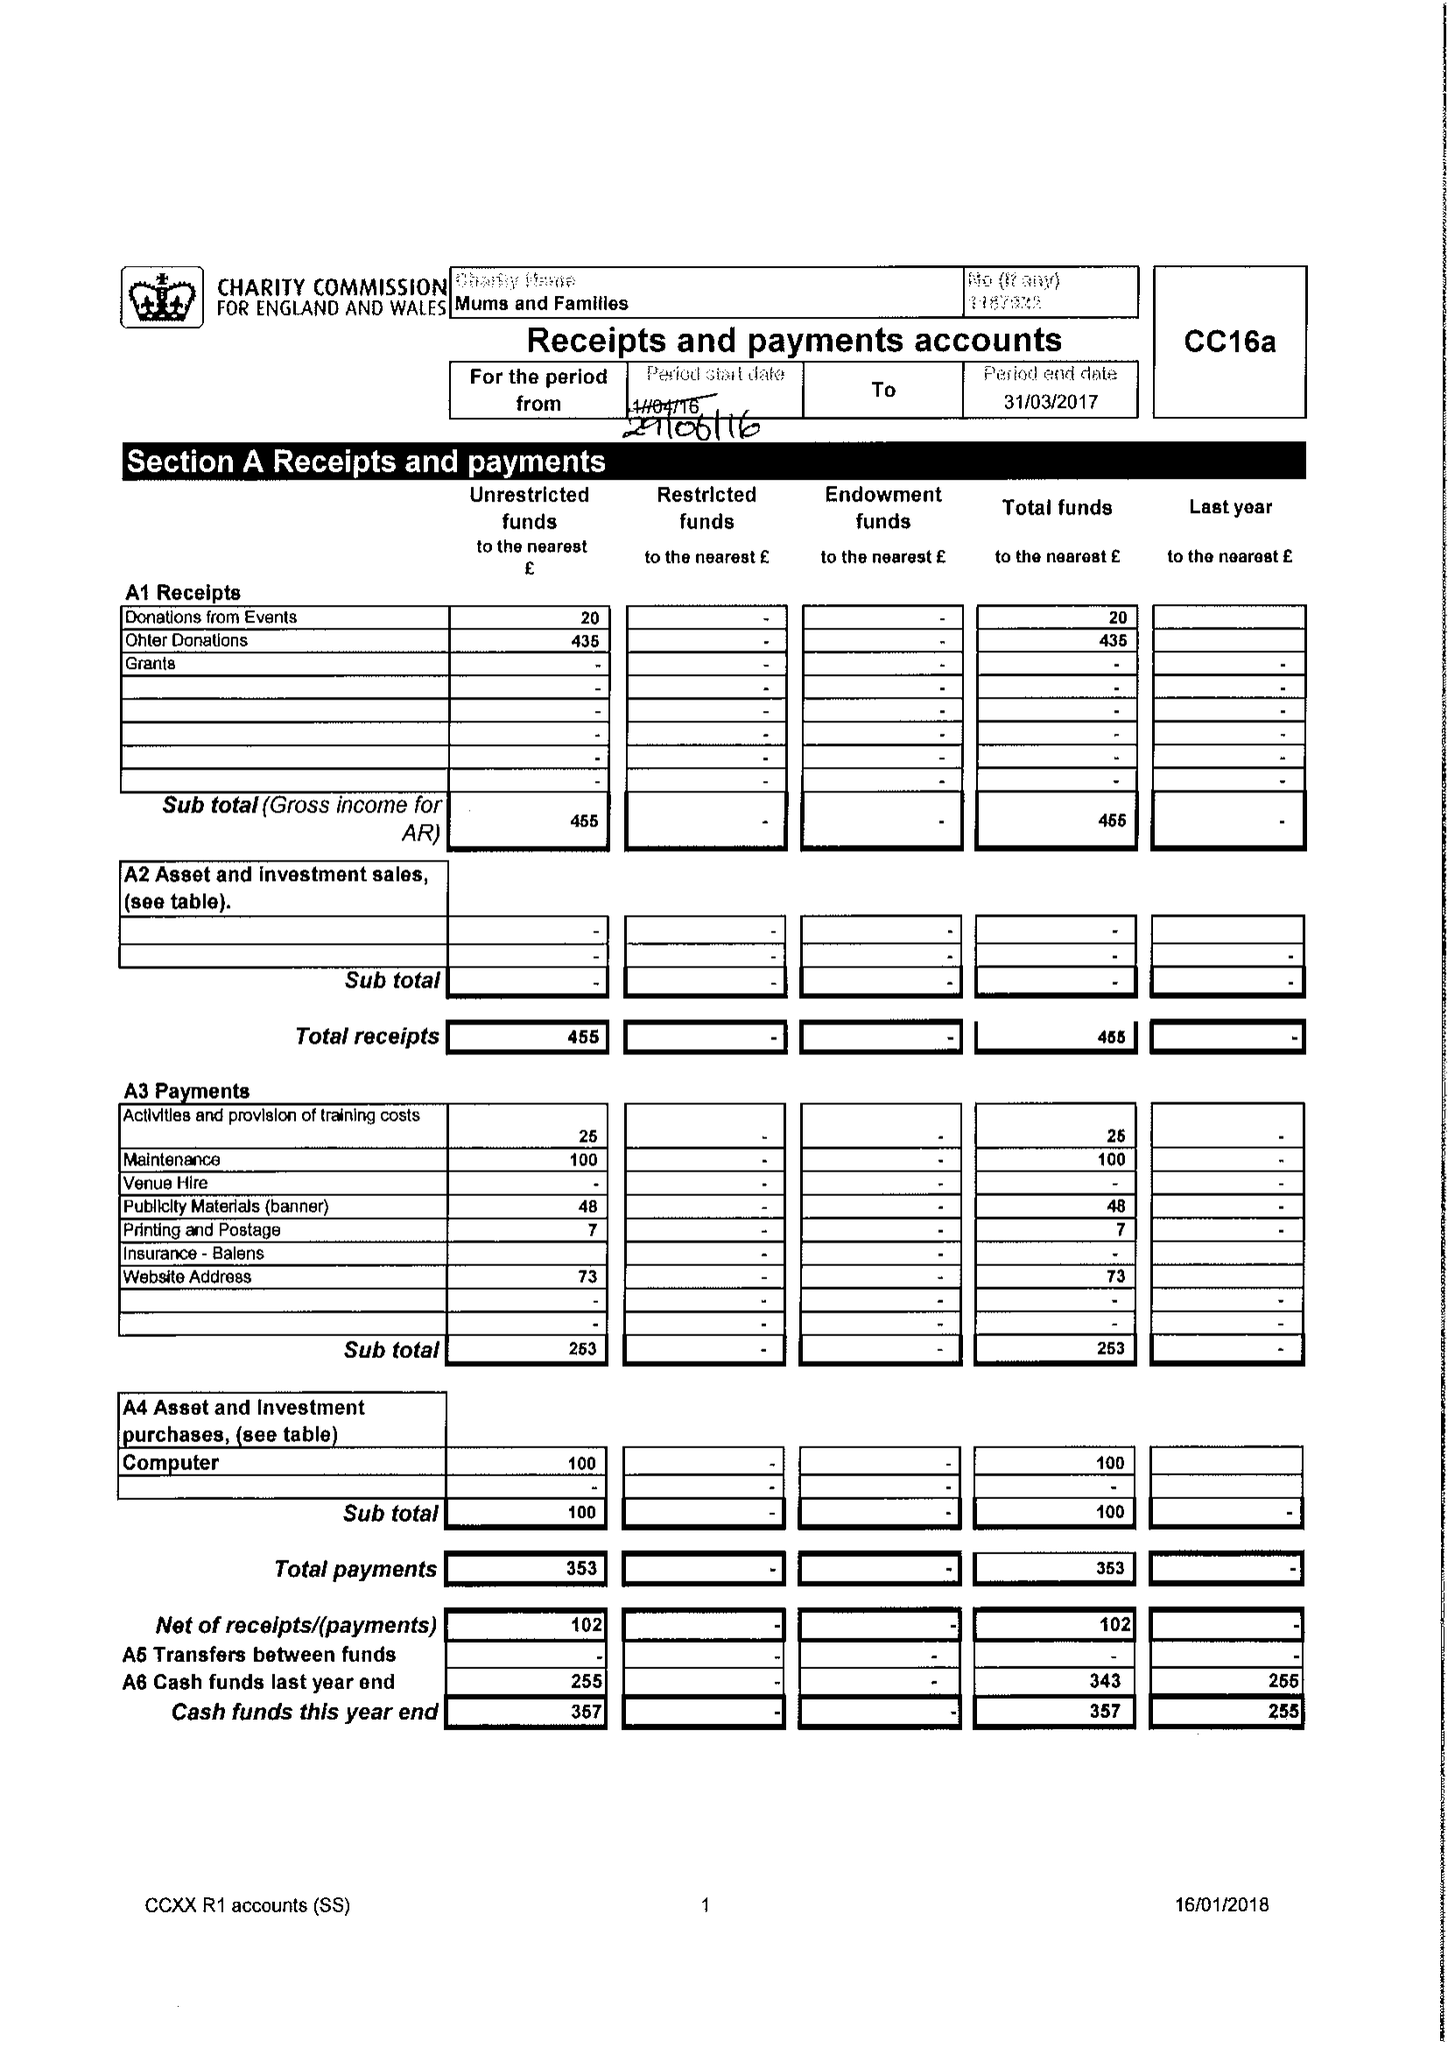What is the value for the spending_annually_in_british_pounds?
Answer the question using a single word or phrase. 353.00 